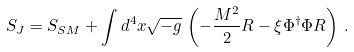Convert formula to latex. <formula><loc_0><loc_0><loc_500><loc_500>S _ { J } = S _ { S M } + \int d ^ { 4 } x \sqrt { - g } \, \left ( - \frac { M ^ { 2 } } { 2 } R - \xi \Phi ^ { \dagger } \Phi R \right ) \, .</formula> 